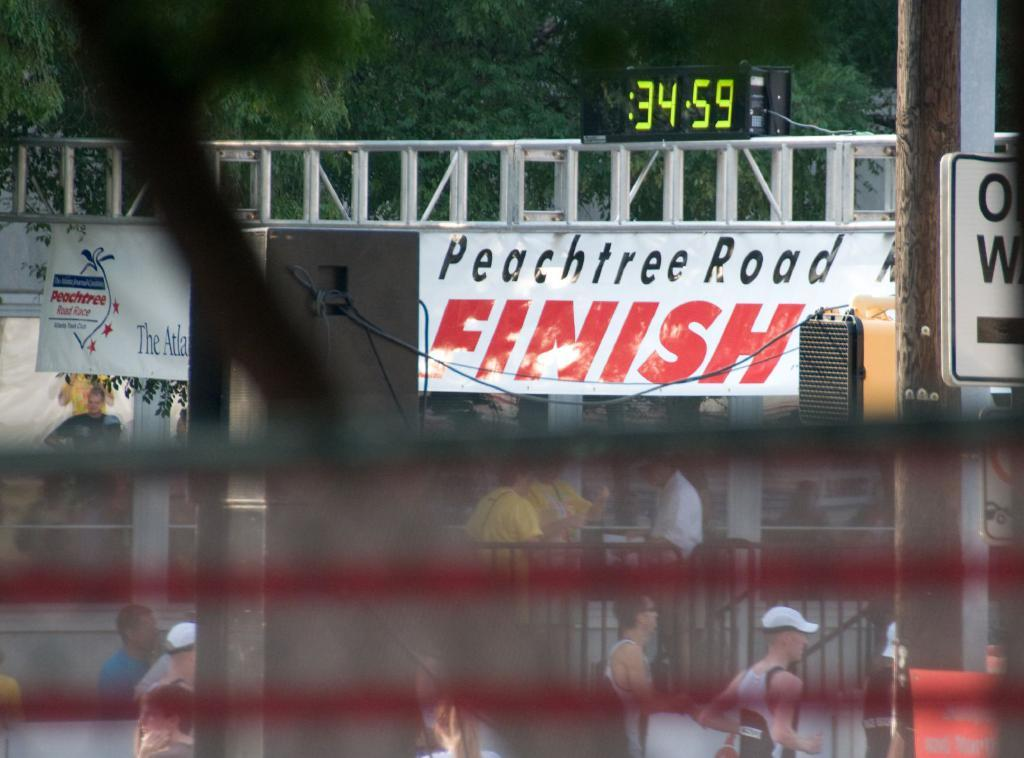What is located in the foreground of the image? There is a banner and a timer attached to a rod in the foreground of the image. What can be seen on the road in the bottom part of the image? There are people visible on the road in the bottom part of the image. What type of vegetation is visible in the top part of the image? There are trees visible in the top part of the image. What type of bait is the person on the road using in the image? There is no person using bait in the image; it features a banner, a timer, and people on the road. How does the hope change the appearance of the trees in the image? There is no mention of hope in the image, and the appearance of the trees is not affected by any emotional state. 